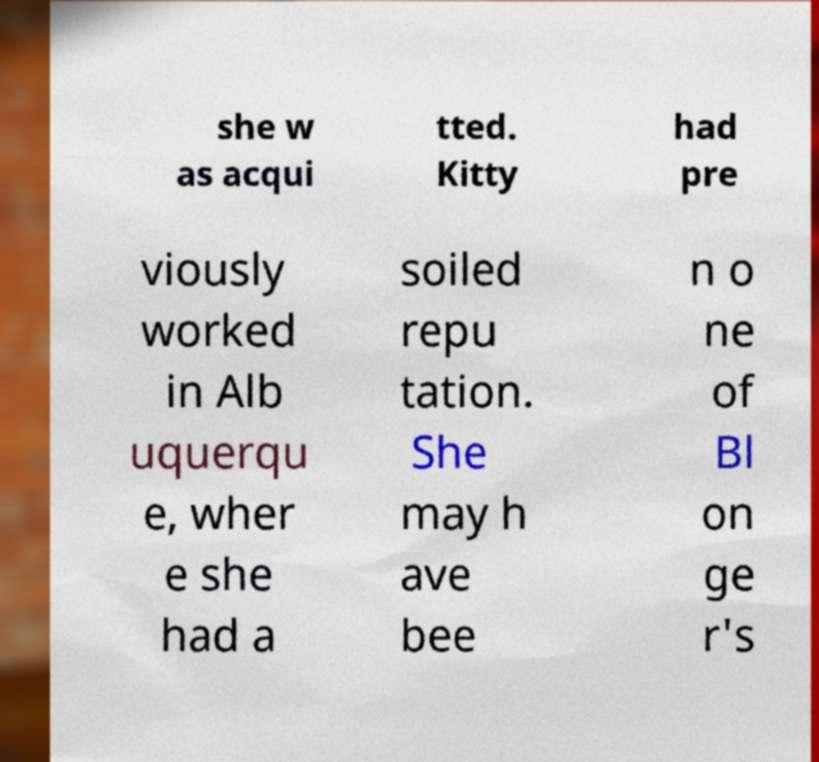Can you accurately transcribe the text from the provided image for me? she w as acqui tted. Kitty had pre viously worked in Alb uquerqu e, wher e she had a soiled repu tation. She may h ave bee n o ne of Bl on ge r's 